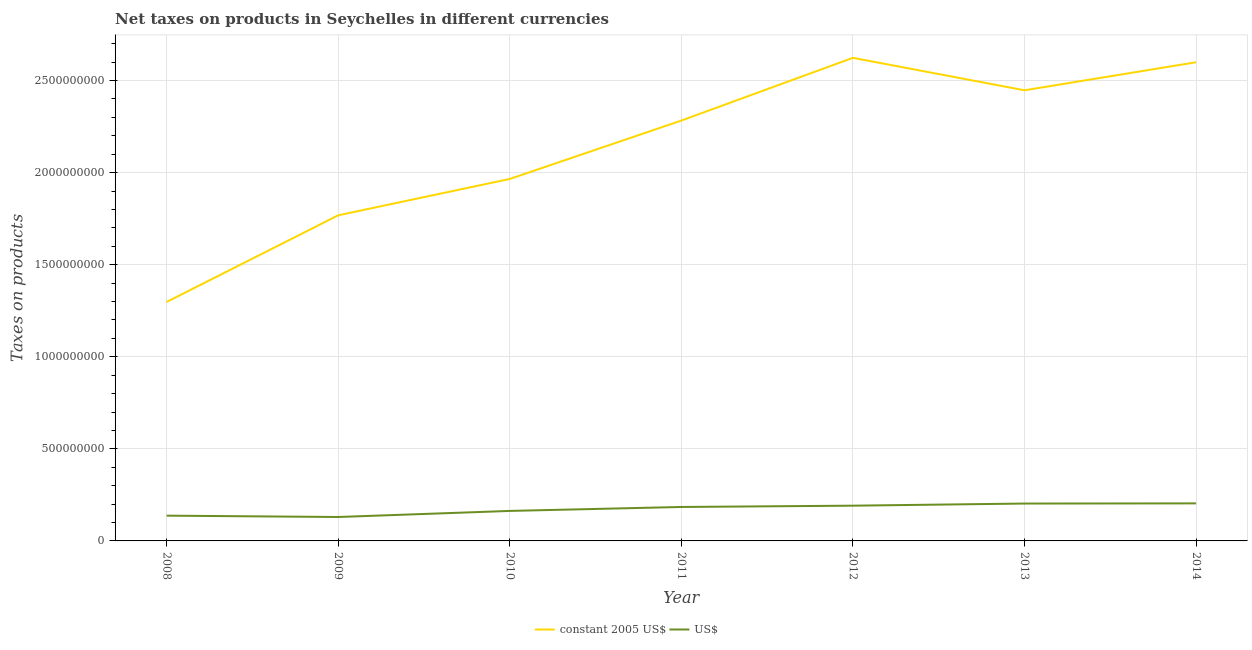Does the line corresponding to net taxes in us$ intersect with the line corresponding to net taxes in constant 2005 us$?
Offer a very short reply. No. What is the net taxes in constant 2005 us$ in 2011?
Provide a succinct answer. 2.28e+09. Across all years, what is the maximum net taxes in us$?
Ensure brevity in your answer.  2.04e+08. Across all years, what is the minimum net taxes in us$?
Keep it short and to the point. 1.30e+08. In which year was the net taxes in us$ maximum?
Offer a very short reply. 2014. In which year was the net taxes in constant 2005 us$ minimum?
Your answer should be very brief. 2008. What is the total net taxes in us$ in the graph?
Your answer should be compact. 1.21e+09. What is the difference between the net taxes in constant 2005 us$ in 2008 and that in 2010?
Your answer should be very brief. -6.68e+08. What is the difference between the net taxes in us$ in 2012 and the net taxes in constant 2005 us$ in 2013?
Your answer should be very brief. -2.26e+09. What is the average net taxes in constant 2005 us$ per year?
Make the answer very short. 2.14e+09. In the year 2014, what is the difference between the net taxes in constant 2005 us$ and net taxes in us$?
Ensure brevity in your answer.  2.40e+09. What is the ratio of the net taxes in constant 2005 us$ in 2009 to that in 2011?
Offer a very short reply. 0.77. What is the difference between the highest and the second highest net taxes in constant 2005 us$?
Offer a very short reply. 2.40e+07. What is the difference between the highest and the lowest net taxes in us$?
Your answer should be very brief. 7.40e+07. In how many years, is the net taxes in us$ greater than the average net taxes in us$ taken over all years?
Your answer should be very brief. 4. Is the net taxes in us$ strictly greater than the net taxes in constant 2005 us$ over the years?
Provide a succinct answer. No. How many years are there in the graph?
Your answer should be very brief. 7. Does the graph contain grids?
Your answer should be very brief. Yes. How are the legend labels stacked?
Ensure brevity in your answer.  Horizontal. What is the title of the graph?
Your answer should be compact. Net taxes on products in Seychelles in different currencies. Does "Public funds" appear as one of the legend labels in the graph?
Your response must be concise. No. What is the label or title of the X-axis?
Provide a short and direct response. Year. What is the label or title of the Y-axis?
Your answer should be compact. Taxes on products. What is the Taxes on products of constant 2005 US$ in 2008?
Your answer should be compact. 1.30e+09. What is the Taxes on products in US$ in 2008?
Your response must be concise. 1.37e+08. What is the Taxes on products in constant 2005 US$ in 2009?
Offer a terse response. 1.77e+09. What is the Taxes on products in US$ in 2009?
Your answer should be compact. 1.30e+08. What is the Taxes on products in constant 2005 US$ in 2010?
Provide a succinct answer. 1.97e+09. What is the Taxes on products in US$ in 2010?
Offer a terse response. 1.63e+08. What is the Taxes on products of constant 2005 US$ in 2011?
Your answer should be compact. 2.28e+09. What is the Taxes on products in US$ in 2011?
Offer a terse response. 1.84e+08. What is the Taxes on products of constant 2005 US$ in 2012?
Offer a very short reply. 2.62e+09. What is the Taxes on products of US$ in 2012?
Keep it short and to the point. 1.91e+08. What is the Taxes on products in constant 2005 US$ in 2013?
Your answer should be very brief. 2.45e+09. What is the Taxes on products of US$ in 2013?
Offer a very short reply. 2.03e+08. What is the Taxes on products of constant 2005 US$ in 2014?
Your answer should be compact. 2.60e+09. What is the Taxes on products of US$ in 2014?
Your response must be concise. 2.04e+08. Across all years, what is the maximum Taxes on products of constant 2005 US$?
Keep it short and to the point. 2.62e+09. Across all years, what is the maximum Taxes on products in US$?
Offer a terse response. 2.04e+08. Across all years, what is the minimum Taxes on products in constant 2005 US$?
Offer a terse response. 1.30e+09. Across all years, what is the minimum Taxes on products of US$?
Give a very brief answer. 1.30e+08. What is the total Taxes on products in constant 2005 US$ in the graph?
Give a very brief answer. 1.50e+1. What is the total Taxes on products of US$ in the graph?
Offer a terse response. 1.21e+09. What is the difference between the Taxes on products of constant 2005 US$ in 2008 and that in 2009?
Your answer should be very brief. -4.70e+08. What is the difference between the Taxes on products in US$ in 2008 and that in 2009?
Your answer should be compact. 7.30e+06. What is the difference between the Taxes on products in constant 2005 US$ in 2008 and that in 2010?
Ensure brevity in your answer.  -6.68e+08. What is the difference between the Taxes on products in US$ in 2008 and that in 2010?
Your response must be concise. -2.57e+07. What is the difference between the Taxes on products in constant 2005 US$ in 2008 and that in 2011?
Provide a short and direct response. -9.85e+08. What is the difference between the Taxes on products in US$ in 2008 and that in 2011?
Your answer should be compact. -4.71e+07. What is the difference between the Taxes on products in constant 2005 US$ in 2008 and that in 2012?
Offer a terse response. -1.33e+09. What is the difference between the Taxes on products of US$ in 2008 and that in 2012?
Give a very brief answer. -5.42e+07. What is the difference between the Taxes on products in constant 2005 US$ in 2008 and that in 2013?
Your answer should be compact. -1.15e+09. What is the difference between the Taxes on products in US$ in 2008 and that in 2013?
Offer a terse response. -6.57e+07. What is the difference between the Taxes on products in constant 2005 US$ in 2008 and that in 2014?
Keep it short and to the point. -1.30e+09. What is the difference between the Taxes on products in US$ in 2008 and that in 2014?
Your answer should be compact. -6.67e+07. What is the difference between the Taxes on products in constant 2005 US$ in 2009 and that in 2010?
Provide a short and direct response. -1.97e+08. What is the difference between the Taxes on products in US$ in 2009 and that in 2010?
Your answer should be very brief. -3.30e+07. What is the difference between the Taxes on products in constant 2005 US$ in 2009 and that in 2011?
Offer a very short reply. -5.14e+08. What is the difference between the Taxes on products in US$ in 2009 and that in 2011?
Your answer should be very brief. -5.44e+07. What is the difference between the Taxes on products of constant 2005 US$ in 2009 and that in 2012?
Your answer should be compact. -8.55e+08. What is the difference between the Taxes on products of US$ in 2009 and that in 2012?
Your answer should be very brief. -6.15e+07. What is the difference between the Taxes on products of constant 2005 US$ in 2009 and that in 2013?
Offer a very short reply. -6.79e+08. What is the difference between the Taxes on products of US$ in 2009 and that in 2013?
Offer a very short reply. -7.30e+07. What is the difference between the Taxes on products in constant 2005 US$ in 2009 and that in 2014?
Offer a terse response. -8.31e+08. What is the difference between the Taxes on products of US$ in 2009 and that in 2014?
Offer a very short reply. -7.40e+07. What is the difference between the Taxes on products of constant 2005 US$ in 2010 and that in 2011?
Your answer should be very brief. -3.17e+08. What is the difference between the Taxes on products in US$ in 2010 and that in 2011?
Offer a very short reply. -2.15e+07. What is the difference between the Taxes on products of constant 2005 US$ in 2010 and that in 2012?
Your response must be concise. -6.58e+08. What is the difference between the Taxes on products of US$ in 2010 and that in 2012?
Your answer should be compact. -2.85e+07. What is the difference between the Taxes on products in constant 2005 US$ in 2010 and that in 2013?
Your answer should be very brief. -4.81e+08. What is the difference between the Taxes on products in US$ in 2010 and that in 2013?
Keep it short and to the point. -4.01e+07. What is the difference between the Taxes on products of constant 2005 US$ in 2010 and that in 2014?
Give a very brief answer. -6.34e+08. What is the difference between the Taxes on products of US$ in 2010 and that in 2014?
Your answer should be very brief. -4.10e+07. What is the difference between the Taxes on products of constant 2005 US$ in 2011 and that in 2012?
Give a very brief answer. -3.41e+08. What is the difference between the Taxes on products in US$ in 2011 and that in 2012?
Keep it short and to the point. -7.06e+06. What is the difference between the Taxes on products in constant 2005 US$ in 2011 and that in 2013?
Make the answer very short. -1.64e+08. What is the difference between the Taxes on products of US$ in 2011 and that in 2013?
Your answer should be very brief. -1.86e+07. What is the difference between the Taxes on products of constant 2005 US$ in 2011 and that in 2014?
Offer a very short reply. -3.17e+08. What is the difference between the Taxes on products in US$ in 2011 and that in 2014?
Your response must be concise. -1.96e+07. What is the difference between the Taxes on products of constant 2005 US$ in 2012 and that in 2013?
Provide a short and direct response. 1.76e+08. What is the difference between the Taxes on products in US$ in 2012 and that in 2013?
Give a very brief answer. -1.15e+07. What is the difference between the Taxes on products in constant 2005 US$ in 2012 and that in 2014?
Your answer should be very brief. 2.40e+07. What is the difference between the Taxes on products in US$ in 2012 and that in 2014?
Offer a very short reply. -1.25e+07. What is the difference between the Taxes on products of constant 2005 US$ in 2013 and that in 2014?
Your answer should be very brief. -1.52e+08. What is the difference between the Taxes on products of US$ in 2013 and that in 2014?
Keep it short and to the point. -9.90e+05. What is the difference between the Taxes on products in constant 2005 US$ in 2008 and the Taxes on products in US$ in 2009?
Your answer should be very brief. 1.17e+09. What is the difference between the Taxes on products of constant 2005 US$ in 2008 and the Taxes on products of US$ in 2010?
Offer a very short reply. 1.13e+09. What is the difference between the Taxes on products of constant 2005 US$ in 2008 and the Taxes on products of US$ in 2011?
Offer a very short reply. 1.11e+09. What is the difference between the Taxes on products in constant 2005 US$ in 2008 and the Taxes on products in US$ in 2012?
Make the answer very short. 1.11e+09. What is the difference between the Taxes on products in constant 2005 US$ in 2008 and the Taxes on products in US$ in 2013?
Make the answer very short. 1.09e+09. What is the difference between the Taxes on products of constant 2005 US$ in 2008 and the Taxes on products of US$ in 2014?
Give a very brief answer. 1.09e+09. What is the difference between the Taxes on products in constant 2005 US$ in 2009 and the Taxes on products in US$ in 2010?
Your response must be concise. 1.61e+09. What is the difference between the Taxes on products of constant 2005 US$ in 2009 and the Taxes on products of US$ in 2011?
Give a very brief answer. 1.58e+09. What is the difference between the Taxes on products in constant 2005 US$ in 2009 and the Taxes on products in US$ in 2012?
Your answer should be compact. 1.58e+09. What is the difference between the Taxes on products of constant 2005 US$ in 2009 and the Taxes on products of US$ in 2013?
Your answer should be compact. 1.57e+09. What is the difference between the Taxes on products of constant 2005 US$ in 2009 and the Taxes on products of US$ in 2014?
Make the answer very short. 1.56e+09. What is the difference between the Taxes on products in constant 2005 US$ in 2010 and the Taxes on products in US$ in 2011?
Keep it short and to the point. 1.78e+09. What is the difference between the Taxes on products of constant 2005 US$ in 2010 and the Taxes on products of US$ in 2012?
Keep it short and to the point. 1.77e+09. What is the difference between the Taxes on products of constant 2005 US$ in 2010 and the Taxes on products of US$ in 2013?
Keep it short and to the point. 1.76e+09. What is the difference between the Taxes on products in constant 2005 US$ in 2010 and the Taxes on products in US$ in 2014?
Give a very brief answer. 1.76e+09. What is the difference between the Taxes on products of constant 2005 US$ in 2011 and the Taxes on products of US$ in 2012?
Offer a very short reply. 2.09e+09. What is the difference between the Taxes on products in constant 2005 US$ in 2011 and the Taxes on products in US$ in 2013?
Offer a terse response. 2.08e+09. What is the difference between the Taxes on products of constant 2005 US$ in 2011 and the Taxes on products of US$ in 2014?
Offer a very short reply. 2.08e+09. What is the difference between the Taxes on products of constant 2005 US$ in 2012 and the Taxes on products of US$ in 2013?
Provide a succinct answer. 2.42e+09. What is the difference between the Taxes on products in constant 2005 US$ in 2012 and the Taxes on products in US$ in 2014?
Your answer should be very brief. 2.42e+09. What is the difference between the Taxes on products in constant 2005 US$ in 2013 and the Taxes on products in US$ in 2014?
Keep it short and to the point. 2.24e+09. What is the average Taxes on products in constant 2005 US$ per year?
Provide a short and direct response. 2.14e+09. What is the average Taxes on products of US$ per year?
Your answer should be very brief. 1.73e+08. In the year 2008, what is the difference between the Taxes on products in constant 2005 US$ and Taxes on products in US$?
Your response must be concise. 1.16e+09. In the year 2009, what is the difference between the Taxes on products in constant 2005 US$ and Taxes on products in US$?
Keep it short and to the point. 1.64e+09. In the year 2010, what is the difference between the Taxes on products of constant 2005 US$ and Taxes on products of US$?
Keep it short and to the point. 1.80e+09. In the year 2011, what is the difference between the Taxes on products in constant 2005 US$ and Taxes on products in US$?
Make the answer very short. 2.10e+09. In the year 2012, what is the difference between the Taxes on products in constant 2005 US$ and Taxes on products in US$?
Offer a terse response. 2.43e+09. In the year 2013, what is the difference between the Taxes on products in constant 2005 US$ and Taxes on products in US$?
Your answer should be compact. 2.24e+09. In the year 2014, what is the difference between the Taxes on products of constant 2005 US$ and Taxes on products of US$?
Your answer should be compact. 2.40e+09. What is the ratio of the Taxes on products in constant 2005 US$ in 2008 to that in 2009?
Make the answer very short. 0.73. What is the ratio of the Taxes on products in US$ in 2008 to that in 2009?
Provide a succinct answer. 1.06. What is the ratio of the Taxes on products of constant 2005 US$ in 2008 to that in 2010?
Your answer should be compact. 0.66. What is the ratio of the Taxes on products of US$ in 2008 to that in 2010?
Your answer should be compact. 0.84. What is the ratio of the Taxes on products of constant 2005 US$ in 2008 to that in 2011?
Your answer should be very brief. 0.57. What is the ratio of the Taxes on products of US$ in 2008 to that in 2011?
Your answer should be very brief. 0.74. What is the ratio of the Taxes on products in constant 2005 US$ in 2008 to that in 2012?
Your response must be concise. 0.49. What is the ratio of the Taxes on products in US$ in 2008 to that in 2012?
Provide a succinct answer. 0.72. What is the ratio of the Taxes on products of constant 2005 US$ in 2008 to that in 2013?
Offer a very short reply. 0.53. What is the ratio of the Taxes on products of US$ in 2008 to that in 2013?
Your answer should be very brief. 0.68. What is the ratio of the Taxes on products of constant 2005 US$ in 2008 to that in 2014?
Offer a terse response. 0.5. What is the ratio of the Taxes on products of US$ in 2008 to that in 2014?
Provide a succinct answer. 0.67. What is the ratio of the Taxes on products in constant 2005 US$ in 2009 to that in 2010?
Your response must be concise. 0.9. What is the ratio of the Taxes on products in US$ in 2009 to that in 2010?
Your answer should be very brief. 0.8. What is the ratio of the Taxes on products in constant 2005 US$ in 2009 to that in 2011?
Offer a terse response. 0.77. What is the ratio of the Taxes on products in US$ in 2009 to that in 2011?
Provide a succinct answer. 0.7. What is the ratio of the Taxes on products of constant 2005 US$ in 2009 to that in 2012?
Your answer should be very brief. 0.67. What is the ratio of the Taxes on products of US$ in 2009 to that in 2012?
Offer a terse response. 0.68. What is the ratio of the Taxes on products in constant 2005 US$ in 2009 to that in 2013?
Provide a short and direct response. 0.72. What is the ratio of the Taxes on products in US$ in 2009 to that in 2013?
Your response must be concise. 0.64. What is the ratio of the Taxes on products of constant 2005 US$ in 2009 to that in 2014?
Make the answer very short. 0.68. What is the ratio of the Taxes on products in US$ in 2009 to that in 2014?
Provide a short and direct response. 0.64. What is the ratio of the Taxes on products of constant 2005 US$ in 2010 to that in 2011?
Offer a terse response. 0.86. What is the ratio of the Taxes on products of US$ in 2010 to that in 2011?
Your answer should be very brief. 0.88. What is the ratio of the Taxes on products of constant 2005 US$ in 2010 to that in 2012?
Give a very brief answer. 0.75. What is the ratio of the Taxes on products of US$ in 2010 to that in 2012?
Provide a succinct answer. 0.85. What is the ratio of the Taxes on products in constant 2005 US$ in 2010 to that in 2013?
Your response must be concise. 0.8. What is the ratio of the Taxes on products in US$ in 2010 to that in 2013?
Your answer should be compact. 0.8. What is the ratio of the Taxes on products of constant 2005 US$ in 2010 to that in 2014?
Ensure brevity in your answer.  0.76. What is the ratio of the Taxes on products of US$ in 2010 to that in 2014?
Provide a succinct answer. 0.8. What is the ratio of the Taxes on products in constant 2005 US$ in 2011 to that in 2012?
Make the answer very short. 0.87. What is the ratio of the Taxes on products of US$ in 2011 to that in 2012?
Your answer should be compact. 0.96. What is the ratio of the Taxes on products in constant 2005 US$ in 2011 to that in 2013?
Make the answer very short. 0.93. What is the ratio of the Taxes on products of US$ in 2011 to that in 2013?
Your answer should be compact. 0.91. What is the ratio of the Taxes on products of constant 2005 US$ in 2011 to that in 2014?
Your answer should be compact. 0.88. What is the ratio of the Taxes on products of US$ in 2011 to that in 2014?
Your answer should be compact. 0.9. What is the ratio of the Taxes on products in constant 2005 US$ in 2012 to that in 2013?
Your response must be concise. 1.07. What is the ratio of the Taxes on products in US$ in 2012 to that in 2013?
Your response must be concise. 0.94. What is the ratio of the Taxes on products in constant 2005 US$ in 2012 to that in 2014?
Ensure brevity in your answer.  1.01. What is the ratio of the Taxes on products in US$ in 2012 to that in 2014?
Provide a succinct answer. 0.94. What is the ratio of the Taxes on products in constant 2005 US$ in 2013 to that in 2014?
Provide a succinct answer. 0.94. What is the difference between the highest and the second highest Taxes on products in constant 2005 US$?
Your response must be concise. 2.40e+07. What is the difference between the highest and the second highest Taxes on products of US$?
Make the answer very short. 9.90e+05. What is the difference between the highest and the lowest Taxes on products in constant 2005 US$?
Your answer should be very brief. 1.33e+09. What is the difference between the highest and the lowest Taxes on products in US$?
Your answer should be very brief. 7.40e+07. 